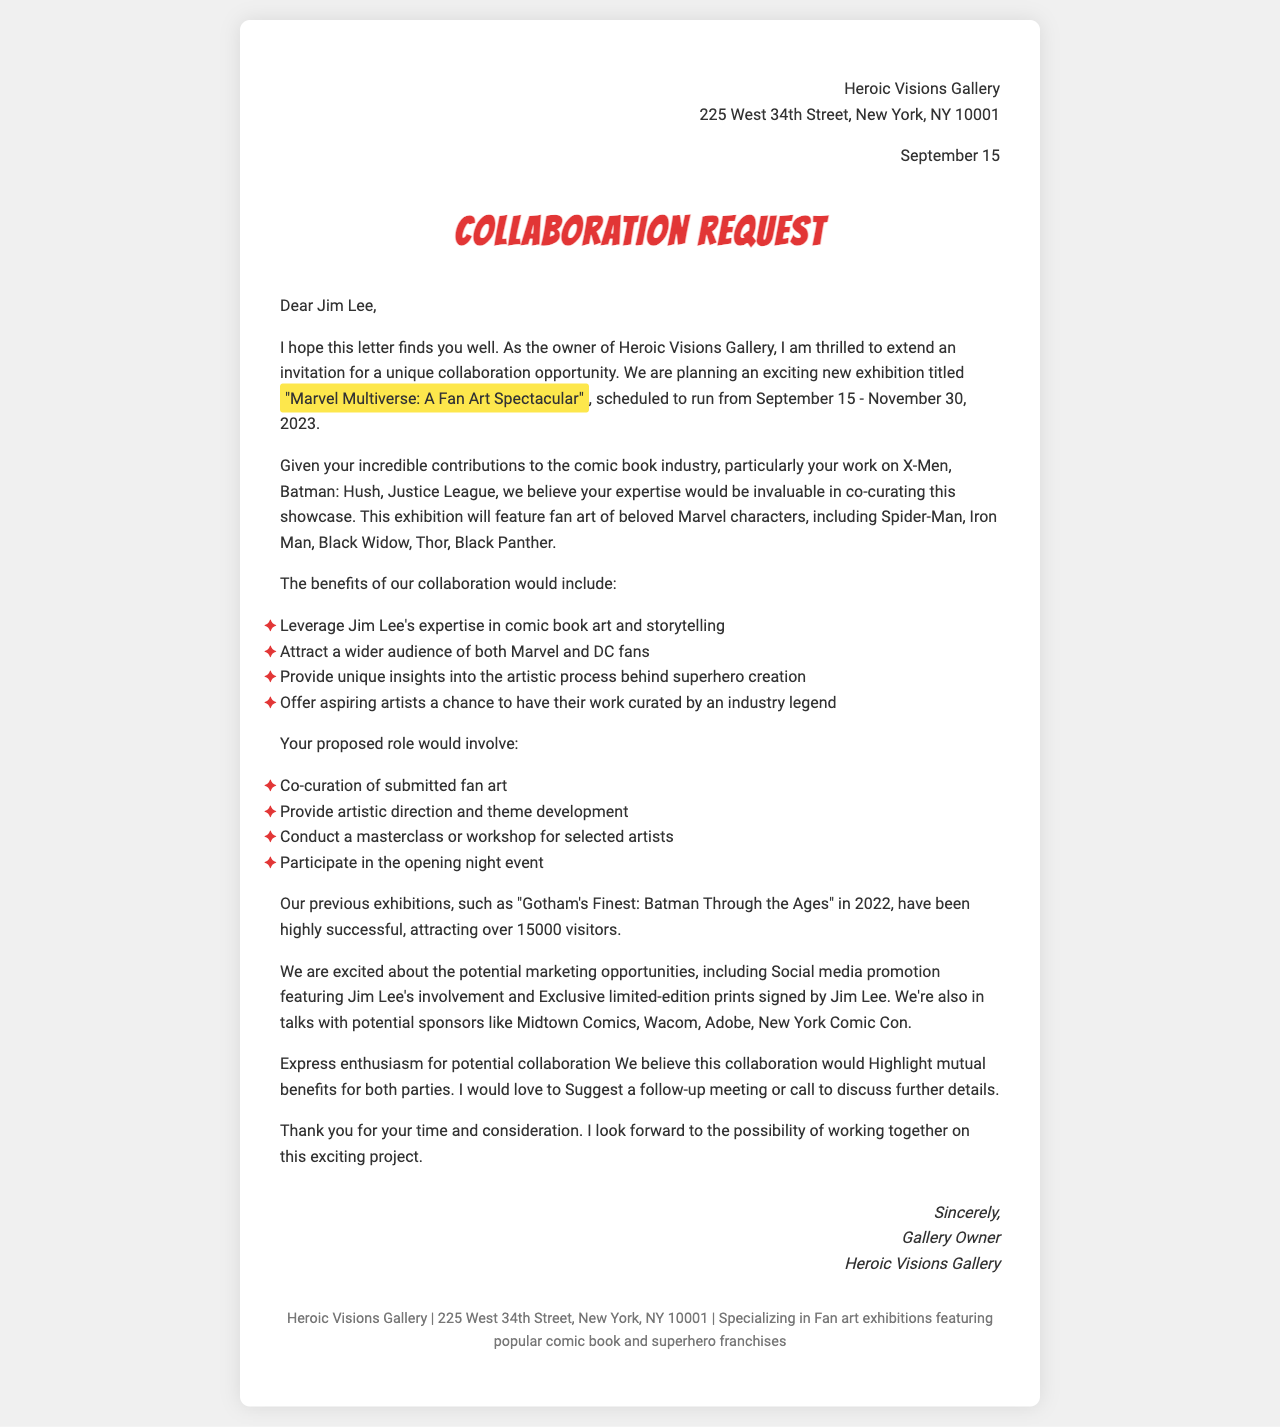What is the name of the gallery? The gallery's name is mentioned at the beginning of the document, indicating the owner's affiliation.
Answer: Heroic Visions Gallery Who is the comic book artist mentioned? The artist's name is explicitly stated in the introduction section of the document.
Answer: Jim Lee What are the proposed exhibition dates? The document outlines specific dates for the exhibition, indicating the timeframe for the event.
Answer: September 15 - November 30, 2023 Which character is NOT featured in the exhibition? This question requires understanding the listed featured characters in the document.
Answer: None (all are featured) What is one benefit of collaboration highlighted in the document? The document lists various benefits, demonstrating the advantages of the collaboration.
Answer: Leverage Jim Lee's expertise in comic book art and storytelling What roles would the gallery owner take on? The document lists specific tasks assigned to the gallery owner for this project, showcasing responsibilities.
Answer: Overall exhibition management, Artist selection and communication, Gallery space preparation and artwork display How many visitors attended the "Gotham's Finest" exhibition? This number is found in the summary of previous exhibitions, reflecting the event's success.
Answer: 15000 What type of marketing opportunity is mentioned? The document specifies certain marketing strategies that will be utilized in the collaboration.
Answer: Social media promotion featuring Jim Lee's involvement What does the letter express enthusiasm for? The overall tone and message of the letter convey excitement about a specific collaboration.
Answer: Potential collaboration 